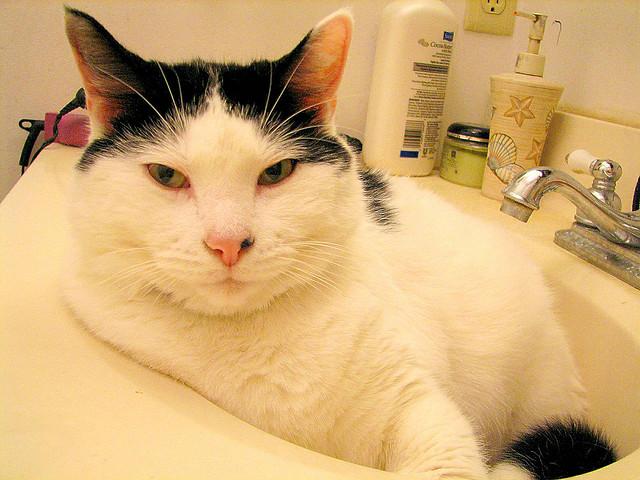Is the cat on a pizza box?
Give a very brief answer. No. Where is the cat sitting?
Give a very brief answer. Sink. Is the cat lying on a microwave oven?
Short answer required. No. What color is the cat?
Quick response, please. White and black. Does this cat want to take a bath?
Short answer required. No. 